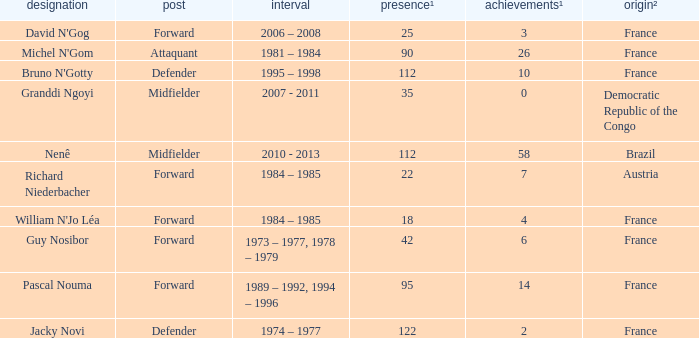How many players are from the country of Brazil? 1.0. 